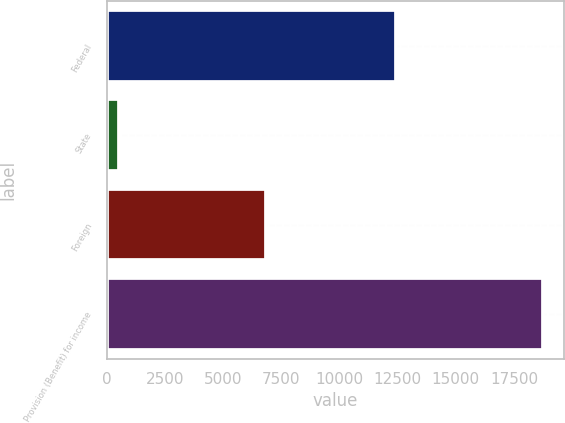Convert chart to OTSL. <chart><loc_0><loc_0><loc_500><loc_500><bar_chart><fcel>Federal<fcel>State<fcel>Foreign<fcel>Provision (Benefit) for income<nl><fcel>12443<fcel>547<fcel>6826<fcel>18733<nl></chart> 